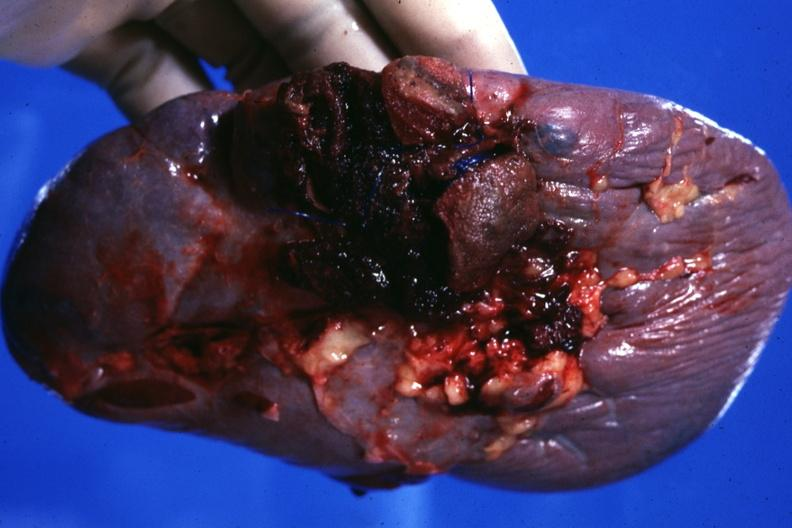what is present?
Answer the question using a single word or phrase. Hematologic 